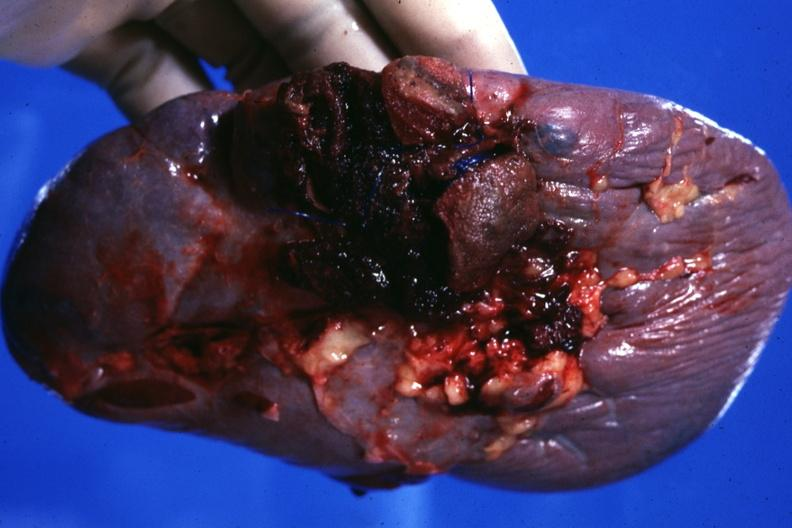what is present?
Answer the question using a single word or phrase. Hematologic 